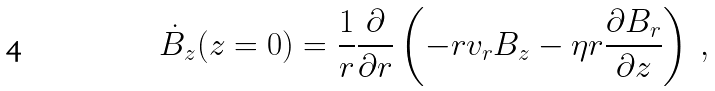<formula> <loc_0><loc_0><loc_500><loc_500>\dot { B } _ { z } ( z = 0 ) = \frac { 1 } { r } \frac { \partial } { \partial r } \left ( - r v _ { r } B _ { z } - \eta r \frac { \partial B _ { r } } { \partial z } \right ) \ ,</formula> 